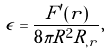<formula> <loc_0><loc_0><loc_500><loc_500>\epsilon = \frac { F ^ { \prime } ( r ) } { 8 \pi R ^ { 2 } R _ { , r } } ,</formula> 